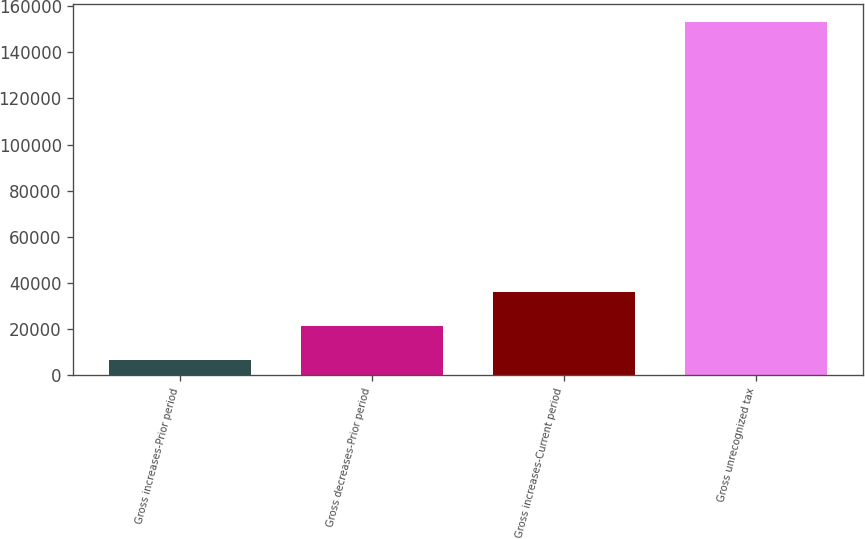Convert chart. <chart><loc_0><loc_0><loc_500><loc_500><bar_chart><fcel>Gross increases-Prior period<fcel>Gross decreases-Prior period<fcel>Gross increases-Current period<fcel>Gross unrecognized tax<nl><fcel>6903<fcel>21531.1<fcel>36159.2<fcel>153184<nl></chart> 